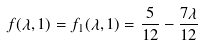<formula> <loc_0><loc_0><loc_500><loc_500>f ( \lambda , 1 ) = f _ { 1 } ( \lambda , 1 ) = \frac { 5 } { 1 2 } - \frac { 7 \lambda } { 1 2 }</formula> 